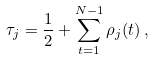<formula> <loc_0><loc_0><loc_500><loc_500>\tau _ { j } = \frac { 1 } { 2 } + \sum _ { t = 1 } ^ { N - 1 } \rho _ { j } ( t ) \, ,</formula> 